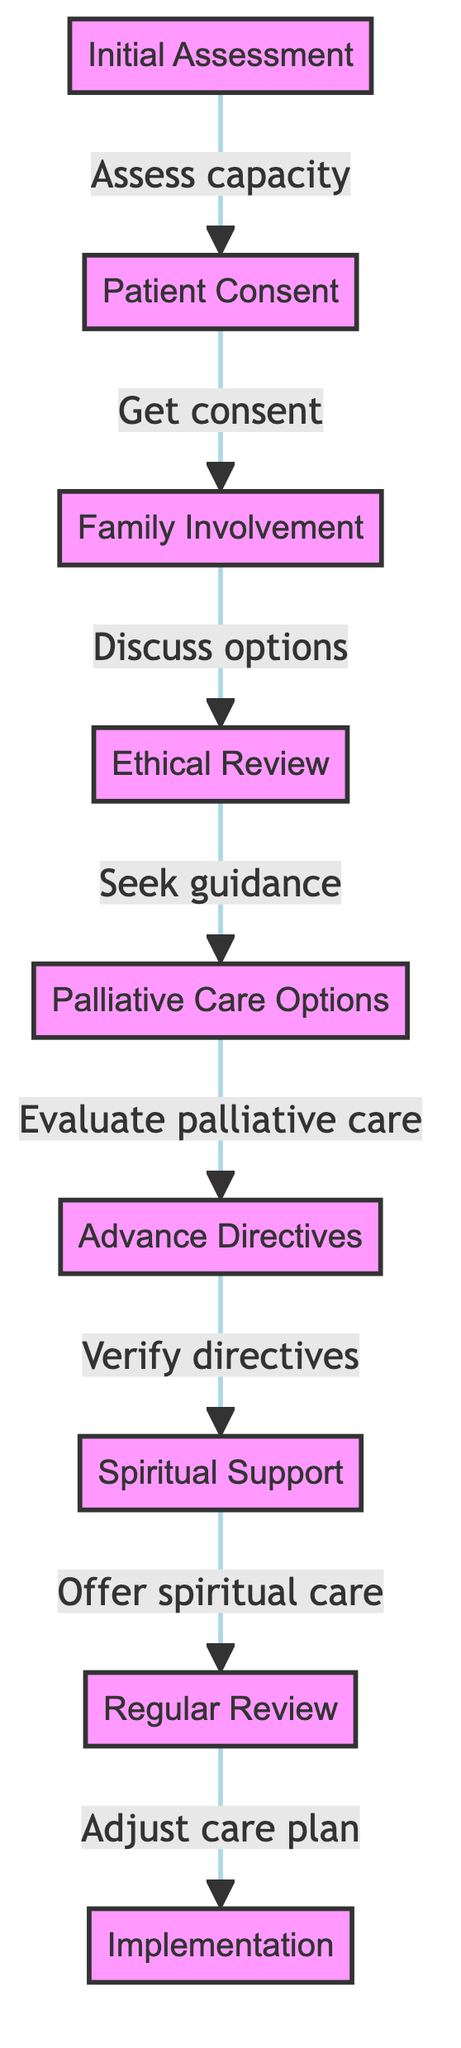What is the starting point of the flowchart? The flowchart begins with the "Initial Assessment" node, indicating the first step in the decision-making process for end-of-life care.
Answer: Initial Assessment How many nodes are present in the diagram? The diagram consists of nine distinct nodes representing various steps in the end-of-life care decision-making process.
Answer: 9 What follows after obtaining patient consent? Following patient consent, the next step is "Family Involvement," indicating the importance of including family members in the decision-making process.
Answer: Family Involvement What option comes after evaluating palliative care? After evaluating palliative care, the next consideration is "Advance Directives," which involves checking for any written instructions from the patient regarding their care preferences.
Answer: Advance Directives Which step involves seeking guidance on ethical considerations? The step "Ethical Review" is where guidance is sought regarding fulfillment of ethical obligations in the context of care decisions.
Answer: Ethical Review What is offered after verifying advance directives? After verifying advance directives, "Spiritual Support" is offered to address the emotional and spiritual needs of the patient and family during this critical time.
Answer: Spiritual Support What is the last step in the flowchart? The final step in the flowchart is "Implementation," which indicates the execution of the adjusted care plan based on the preceding evaluations and discussions.
Answer: Implementation What connects "Family Involvement" and "Ethical Review"? "Family Involvement" connects to "Ethical Review" as the discussion of options necessitates the family's input and agreeing on ethically sound care approaches.
Answer: Discuss options How does the flowchart ensure regular assessment of patient care? The "Regular Review" stage is implemented after spiritual support is offered, ensuring that the care plan is continuously evaluated and modified as necessary.
Answer: Regular Review 